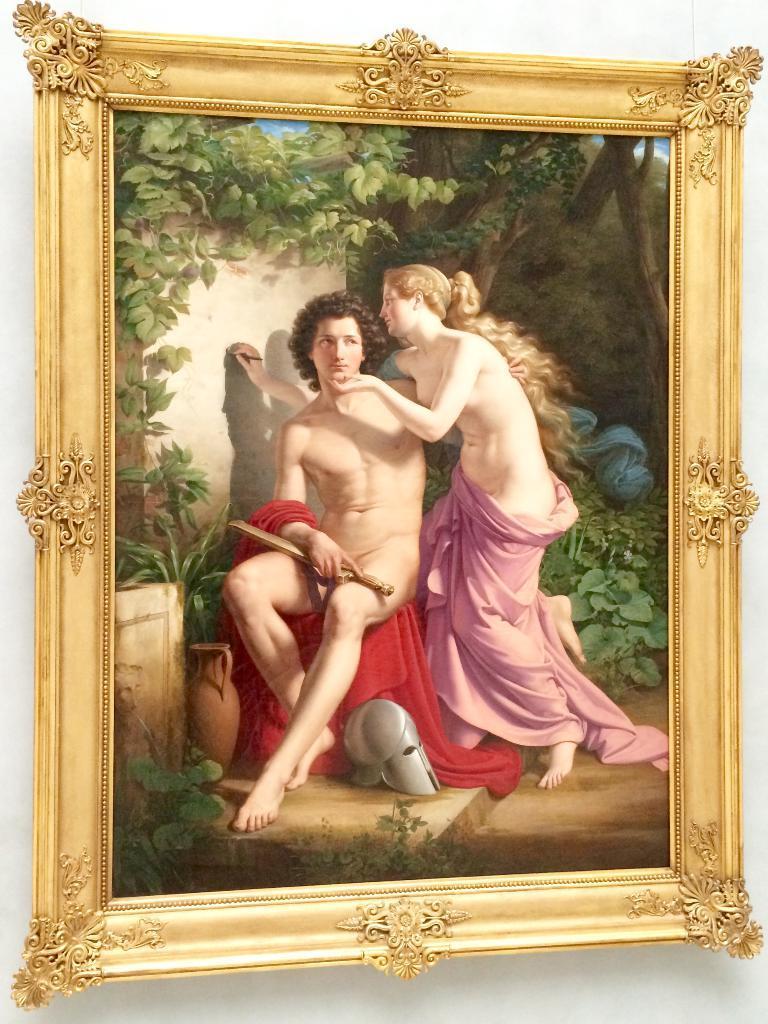Can you describe this image briefly? In this picture we can see a photo frame, there is a painting of two persons and plants in the frame, in the background there is a wall. 